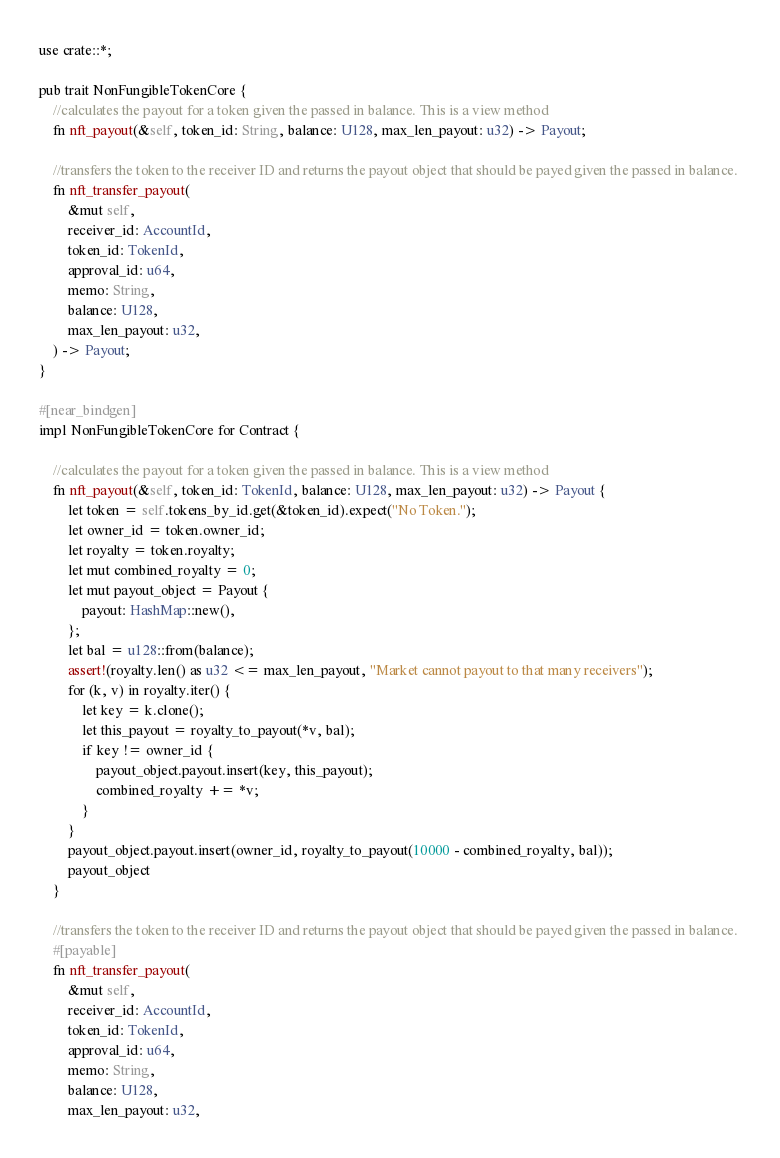<code> <loc_0><loc_0><loc_500><loc_500><_Rust_>use crate::*;

pub trait NonFungibleTokenCore {
    //calculates the payout for a token given the passed in balance. This is a view method
  	fn nft_payout(&self, token_id: String, balance: U128, max_len_payout: u32) -> Payout;
    
    //transfers the token to the receiver ID and returns the payout object that should be payed given the passed in balance. 
    fn nft_transfer_payout(
        &mut self,
        receiver_id: AccountId,
        token_id: TokenId,
        approval_id: u64,
        memo: String,
        balance: U128,
        max_len_payout: u32,
    ) -> Payout;
}

#[near_bindgen]
impl NonFungibleTokenCore for Contract {

    //calculates the payout for a token given the passed in balance. This is a view method
    fn nft_payout(&self, token_id: TokenId, balance: U128, max_len_payout: u32) -> Payout {
		let token = self.tokens_by_id.get(&token_id).expect("No Token.");
        let owner_id = token.owner_id;
        let royalty = token.royalty;
        let mut combined_royalty = 0;
        let mut payout_object = Payout {
            payout: HashMap::new(),
        };
        let bal = u128::from(balance);
        assert!(royalty.len() as u32 <= max_len_payout, "Market cannot payout to that many receivers");
        for (k, v) in royalty.iter() {
            let key = k.clone();
            let this_payout = royalty_to_payout(*v, bal);
            if key != owner_id {
                payout_object.payout.insert(key, this_payout);
                combined_royalty += *v; 
            }
        }
        payout_object.payout.insert(owner_id, royalty_to_payout(10000 - combined_royalty, bal));
        payout_object
	}

    //transfers the token to the receiver ID and returns the payout object that should be payed given the passed in balance. 
    #[payable]
    fn nft_transfer_payout(
        &mut self,
        receiver_id: AccountId,
        token_id: TokenId,
        approval_id: u64,
        memo: String,
        balance: U128,
        max_len_payout: u32,</code> 